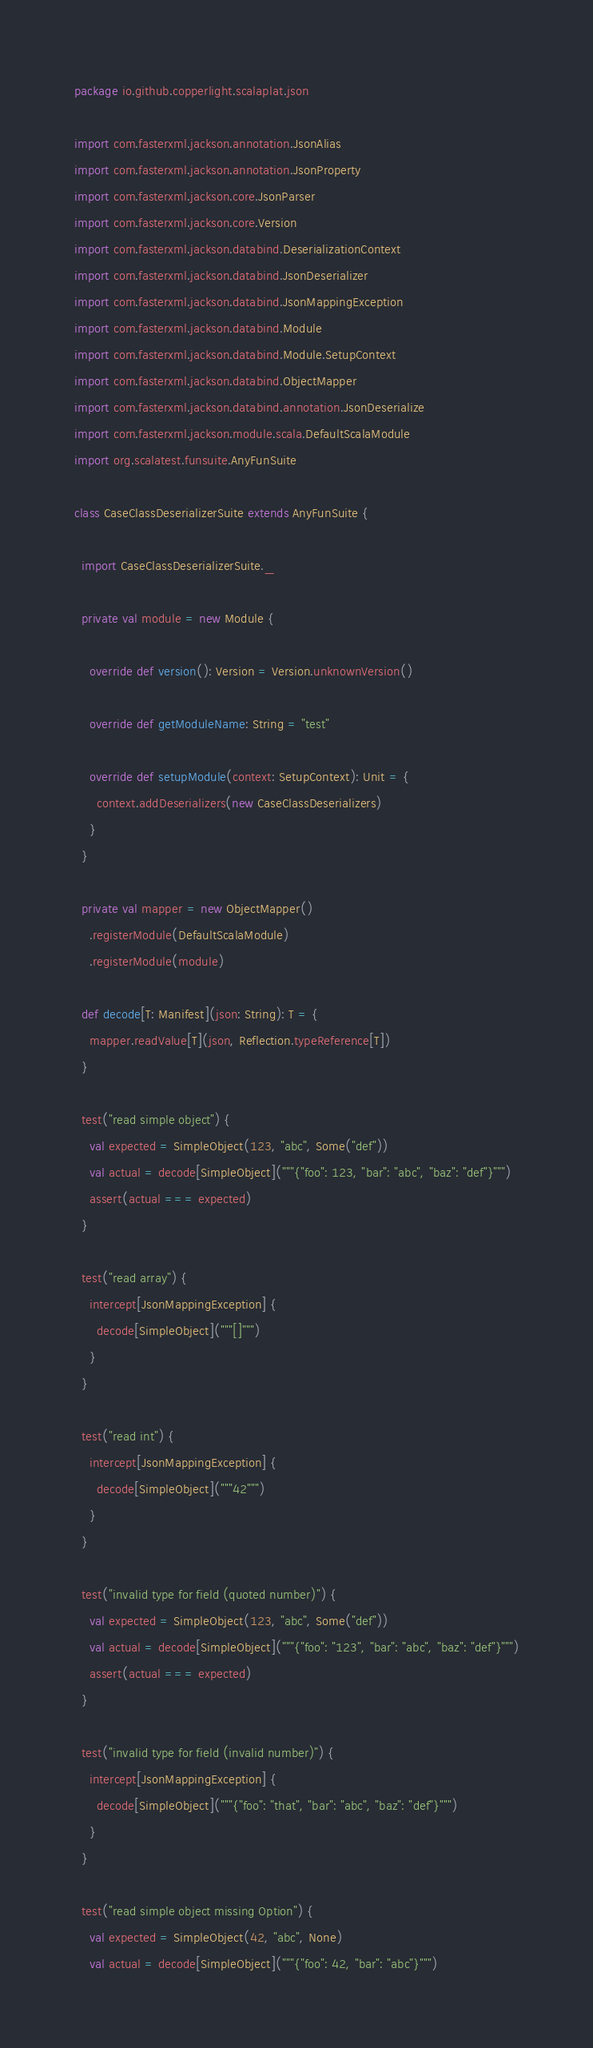<code> <loc_0><loc_0><loc_500><loc_500><_Scala_>package io.github.copperlight.scalaplat.json

import com.fasterxml.jackson.annotation.JsonAlias
import com.fasterxml.jackson.annotation.JsonProperty
import com.fasterxml.jackson.core.JsonParser
import com.fasterxml.jackson.core.Version
import com.fasterxml.jackson.databind.DeserializationContext
import com.fasterxml.jackson.databind.JsonDeserializer
import com.fasterxml.jackson.databind.JsonMappingException
import com.fasterxml.jackson.databind.Module
import com.fasterxml.jackson.databind.Module.SetupContext
import com.fasterxml.jackson.databind.ObjectMapper
import com.fasterxml.jackson.databind.annotation.JsonDeserialize
import com.fasterxml.jackson.module.scala.DefaultScalaModule
import org.scalatest.funsuite.AnyFunSuite

class CaseClassDeserializerSuite extends AnyFunSuite {

  import CaseClassDeserializerSuite._

  private val module = new Module {

    override def version(): Version = Version.unknownVersion()

    override def getModuleName: String = "test"

    override def setupModule(context: SetupContext): Unit = {
      context.addDeserializers(new CaseClassDeserializers)
    }
  }

  private val mapper = new ObjectMapper()
    .registerModule(DefaultScalaModule)
    .registerModule(module)

  def decode[T: Manifest](json: String): T = {
    mapper.readValue[T](json, Reflection.typeReference[T])
  }

  test("read simple object") {
    val expected = SimpleObject(123, "abc", Some("def"))
    val actual = decode[SimpleObject]("""{"foo": 123, "bar": "abc", "baz": "def"}""")
    assert(actual === expected)
  }

  test("read array") {
    intercept[JsonMappingException] {
      decode[SimpleObject]("""[]""")
    }
  }

  test("read int") {
    intercept[JsonMappingException] {
      decode[SimpleObject]("""42""")
    }
  }

  test("invalid type for field (quoted number)") {
    val expected = SimpleObject(123, "abc", Some("def"))
    val actual = decode[SimpleObject]("""{"foo": "123", "bar": "abc", "baz": "def"}""")
    assert(actual === expected)
  }

  test("invalid type for field (invalid number)") {
    intercept[JsonMappingException] {
      decode[SimpleObject]("""{"foo": "that", "bar": "abc", "baz": "def"}""")
    }
  }

  test("read simple object missing Option") {
    val expected = SimpleObject(42, "abc", None)
    val actual = decode[SimpleObject]("""{"foo": 42, "bar": "abc"}""")</code> 